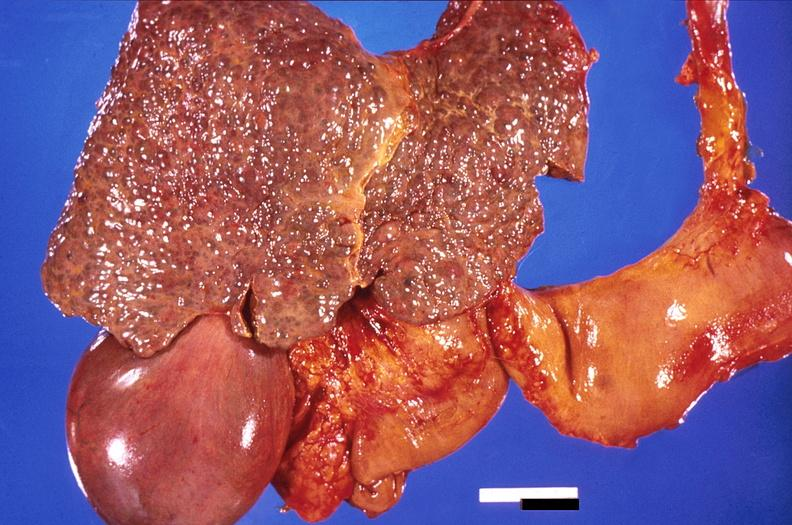what is present?
Answer the question using a single word or phrase. Hepatobiliary 